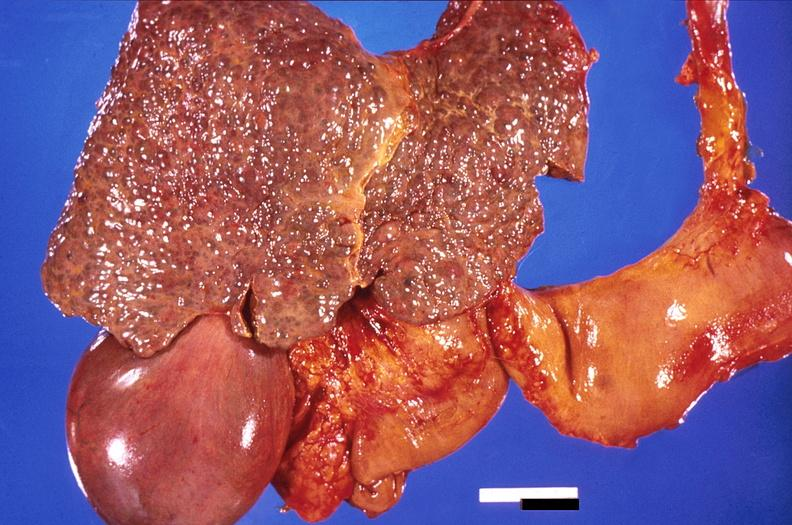what is present?
Answer the question using a single word or phrase. Hepatobiliary 